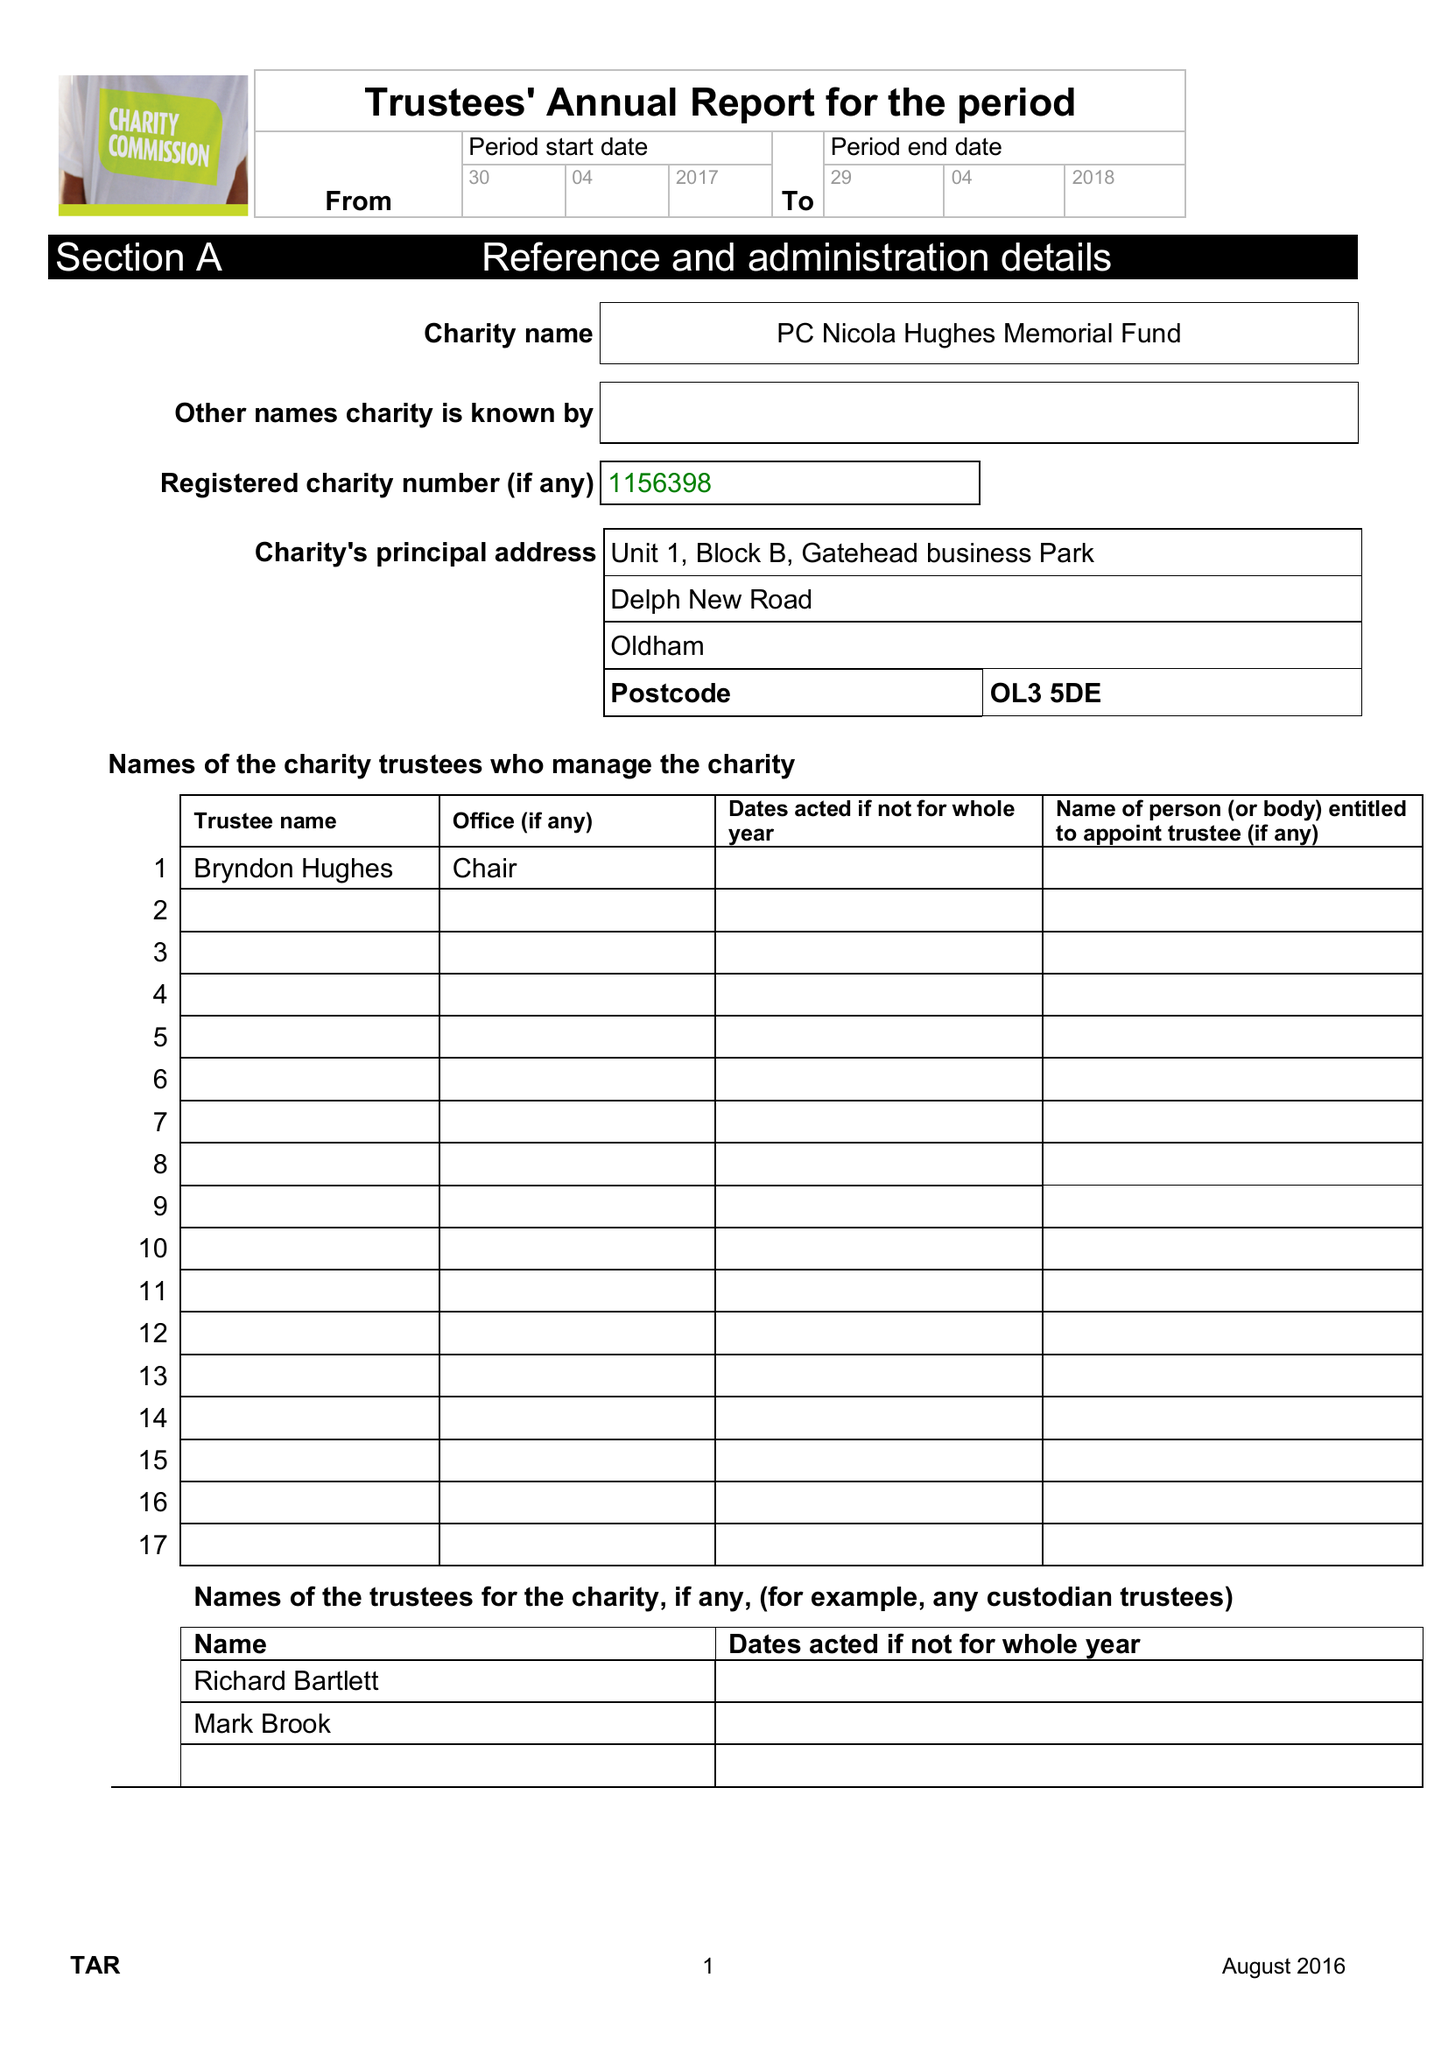What is the value for the income_annually_in_british_pounds?
Answer the question using a single word or phrase. 78300.00 